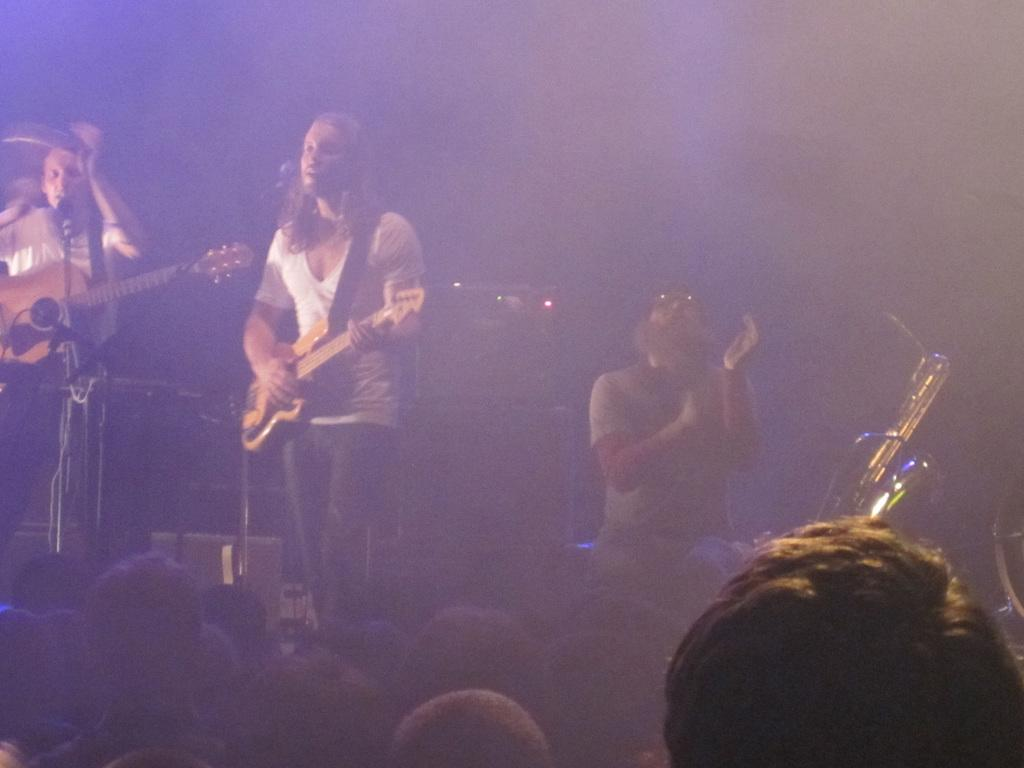How many people are on the stage in the image? There are three persons standing on the stage. What are two of the persons doing on the stage? Two of the persons are playing guitar. What is the remaining person doing on the stage? The remaining person(s) are listening to the guitar performance. Where is the hydrant located in the image? There is no hydrant present in the image. What type of expansion is happening in the image? There is no expansion happening in the image; it is a static scene of people on a stage. 